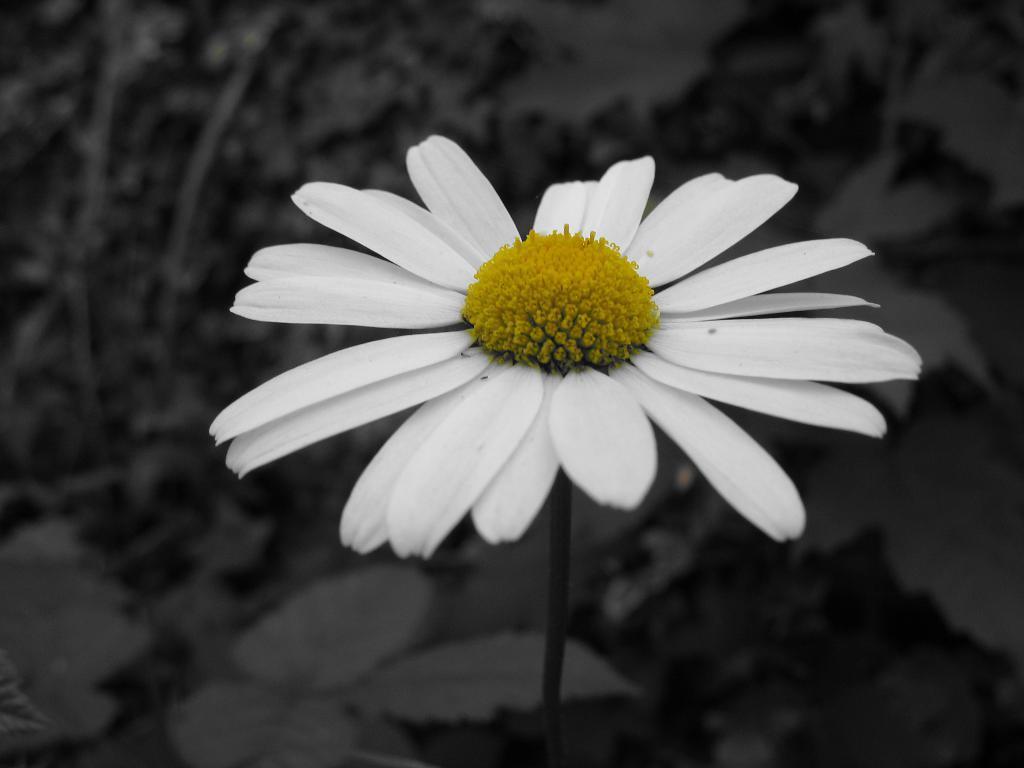Describe this image in one or two sentences. This is an edited image. In this image we can see a flower. 